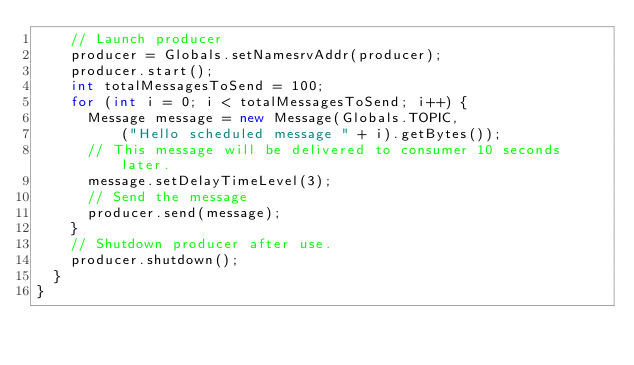<code> <loc_0><loc_0><loc_500><loc_500><_Java_>		// Launch producer
		producer = Globals.setNamesrvAddr(producer);
		producer.start();
		int totalMessagesToSend = 100;
		for (int i = 0; i < totalMessagesToSend; i++) {
			Message message = new Message(Globals.TOPIC,
					("Hello scheduled message " + i).getBytes());
			// This message will be delivered to consumer 10 seconds later.
			message.setDelayTimeLevel(3);
			// Send the message
			producer.send(message);
		}
		// Shutdown producer after use.
		producer.shutdown();
	}
}</code> 